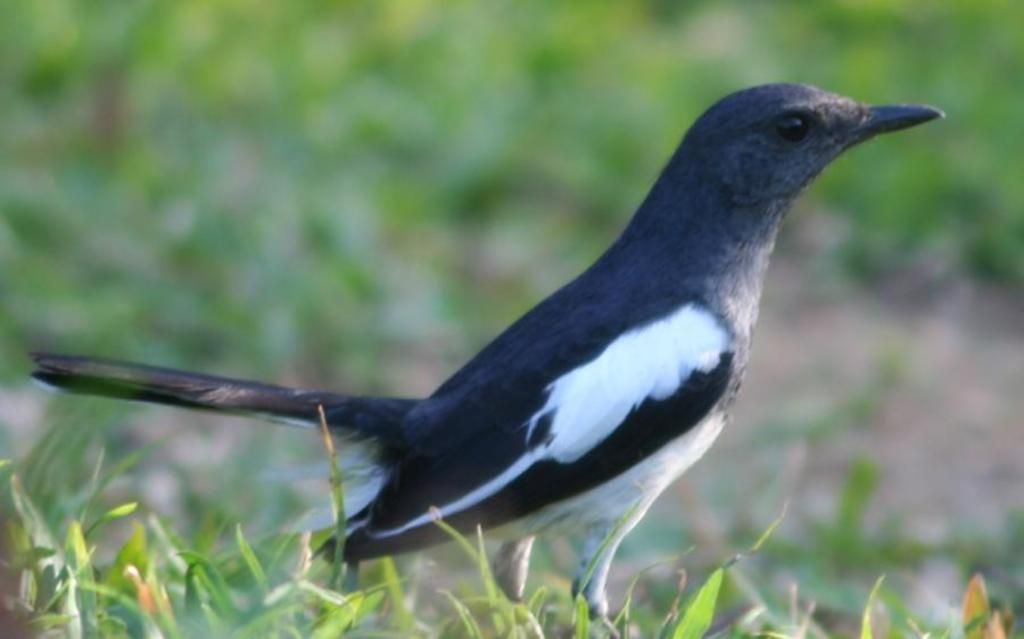What type of natural elements can be seen in the image? There are leaves in the image. What animal is present in the image? There is a bird in the middle of the image. Can you describe the background of the image? The background of the image is blurred. Can you tell me how many babies are present in the image? There are no babies present in the image; it features leaves and a bird. Is the bird touching the leaves in the image? The image does not show the bird touching the leaves, so it cannot be determined from the picture. 